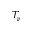Convert formula to latex. <formula><loc_0><loc_0><loc_500><loc_500>T _ { \nu }</formula> 